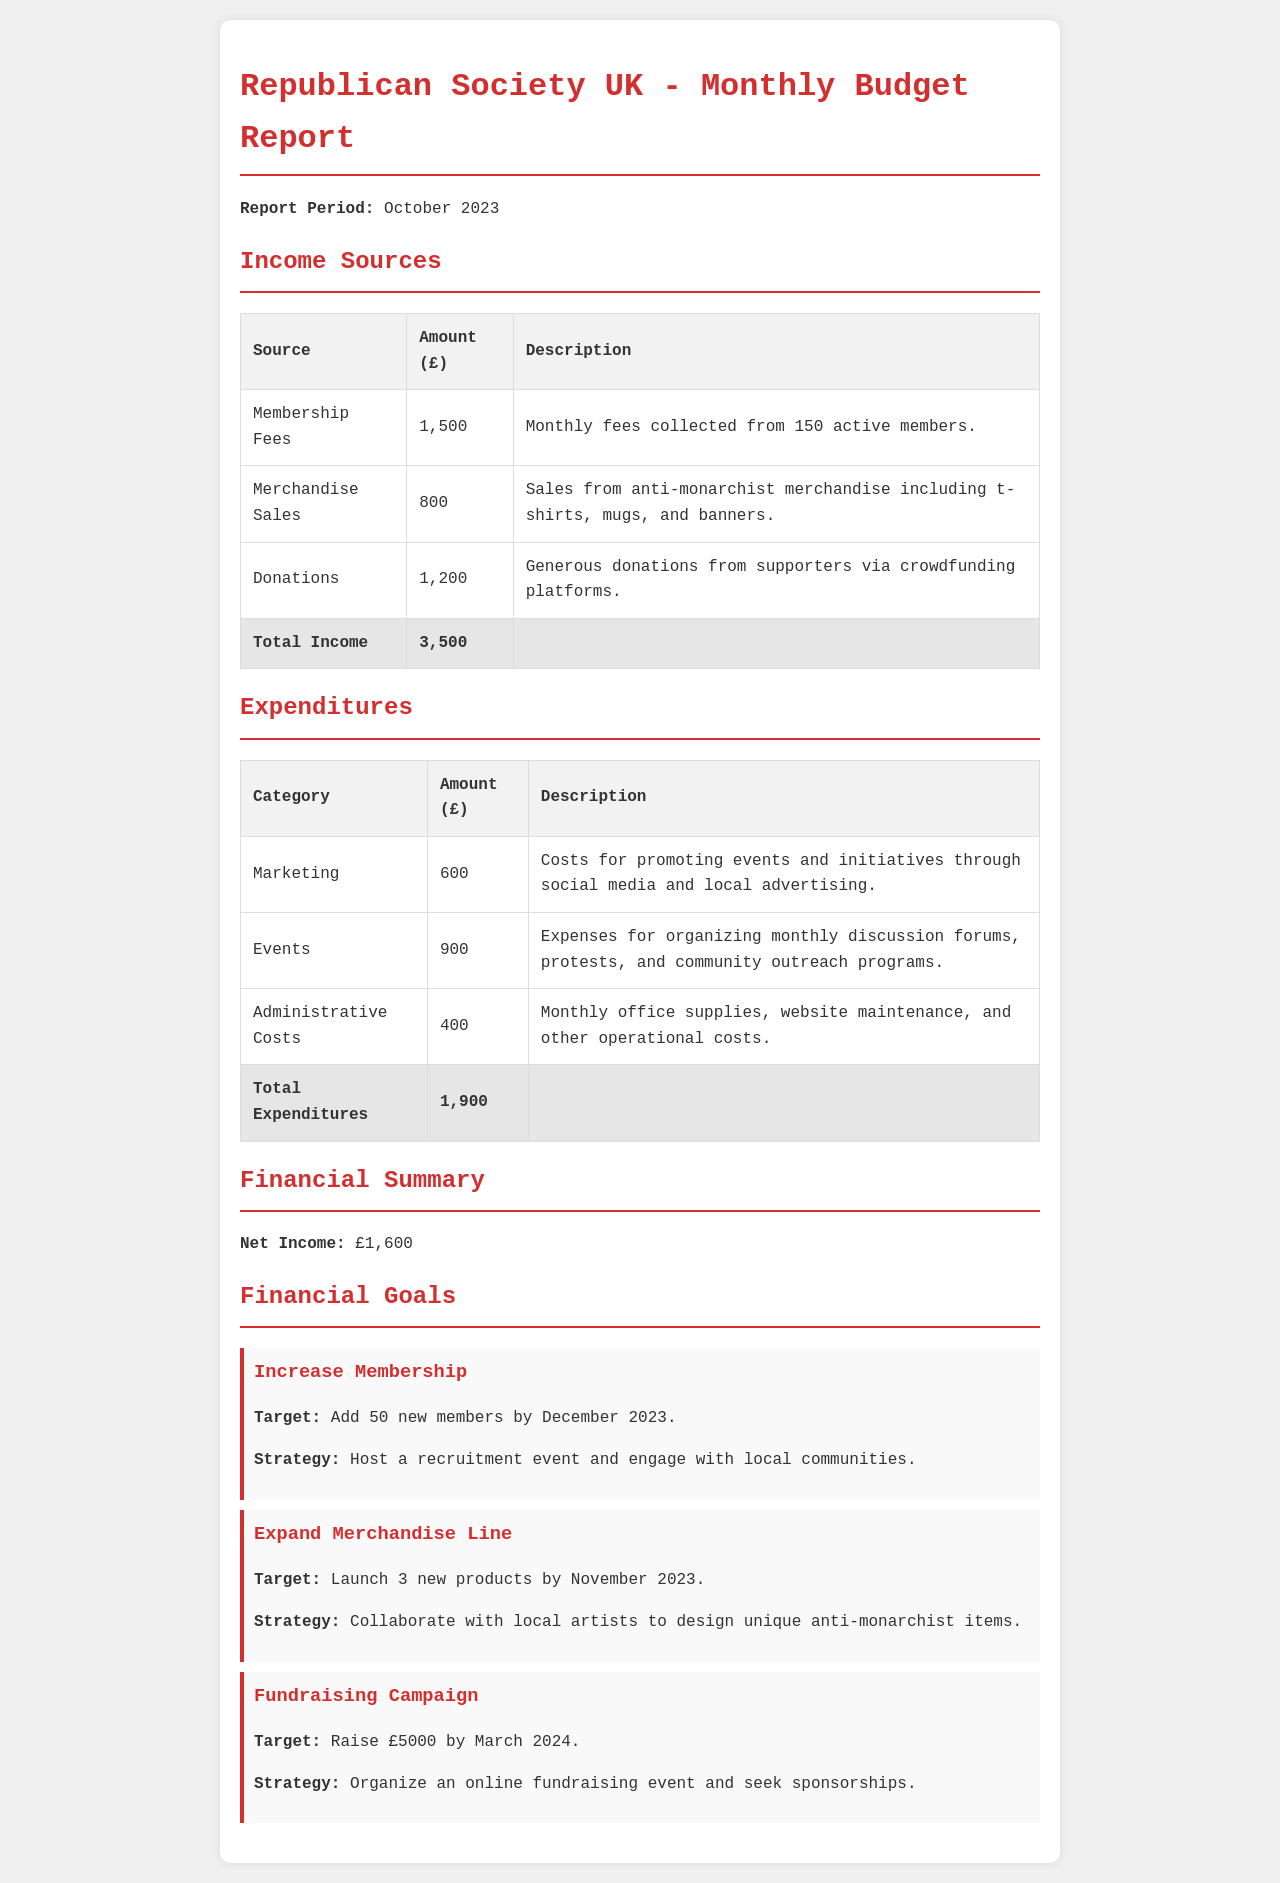What is the total income for October 2023? The total income is the sum of membership fees, merchandise sales, and donations listed in the document.
Answer: £3,500 What is the total expenditure for October 2023? The total expenditure is the sum of marketing, events, and administrative costs listed in the document.
Answer: £1,900 What is the net income for October 2023? The net income is calculated by subtracting the total expenditures from the total income.
Answer: £1,600 How many active members contributed to the membership fees? The number of active members is directly mentioned in the income sources section.
Answer: 150 What is the target for increasing membership by December 2023? The target for membership increase is specified in the financial goals section.
Answer: 50 new members What category has the highest expenditure? The question asks for the category with the highest amount spent among the listed expenditures.
Answer: Events What is the amount raised from donations? The amount collected from donations is specifically stated in the income sources table.
Answer: £1,200 What is the total amount planned to raise from the fundraising campaign? This value is detailed in the financial goals section related to fundraising efforts.
Answer: £5,000 How many new products are planned to be launched by November 2023? The number of new products to be launched is outlined in the financial goals section.
Answer: 3 new products 